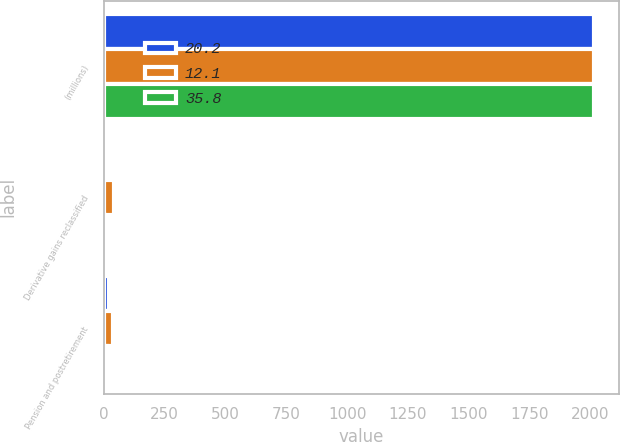Convert chart. <chart><loc_0><loc_0><loc_500><loc_500><stacked_bar_chart><ecel><fcel>(millions)<fcel>Derivative gains reclassified<fcel>Pension and postretirement<nl><fcel>20.2<fcel>2016<fcel>16.9<fcel>20.2<nl><fcel>12.1<fcel>2015<fcel>40.6<fcel>35.8<nl><fcel>35.8<fcel>2014<fcel>3<fcel>12.1<nl></chart> 